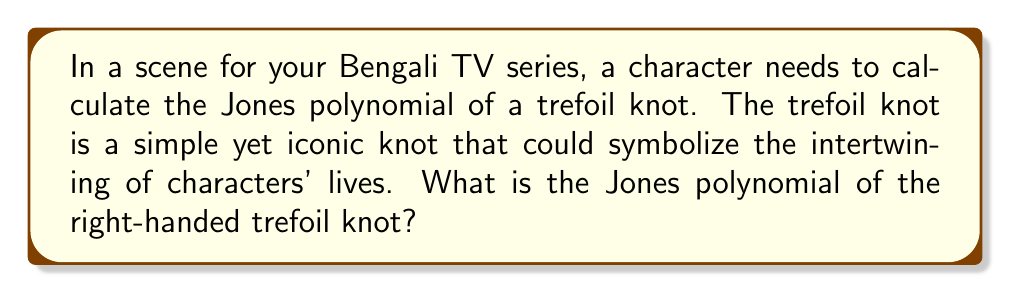Can you solve this math problem? To compute the Jones polynomial of the right-handed trefoil knot, we'll follow these steps:

1. First, we need to orient the trefoil knot and create its diagram:

[asy]
import geometry;

path p = (0,0){dir(60)}..{dir(-60)}(1,0){dir(120)}..{dir(0)}(2,0){dir(-120)}..{dir(180)}cycle;
draw(p, arrow=Arrow(TeXHead));
dot((0,0));
dot((1,0));
dot((2,0));
label("1", (0,0), SW);
label("2", (1,0), S);
label("3", (2,0), SE);
[/asy]

2. We'll use the Kauffman bracket polynomial and then convert it to the Jones polynomial.

3. The Kauffman bracket is calculated using the skein relation:
   $$\langle L_+ \rangle = A\langle L_0 \rangle + A^{-1}\langle L_\infty \rangle$$
   where $A$ is a variable, $L_+$ is the original crossing, $L_0$ is the smoothing that follows the orientation, and $L_\infty$ is the other smoothing.

4. Applying this to each crossing of the trefoil:
   $$\langle \text{trefoil} \rangle = A\langle \text{unknot} \rangle + A^{-1}\langle \text{Hopf link} \rangle$$
   $$= A(-A^2 - A^{-2}) + A^{-1}(-A^3)$$
   $$= -A^3 - A^{-1} - A^{-4}$$

5. The Kauffman bracket of the unknot is $(-A^2 - A^{-2})$, and for the Hopf link, it's $(-A^3)$.

6. To convert the Kauffman bracket to the Jones polynomial, we use:
   $$V_L(t) = (-A^3)^{-w(L)} \langle L \rangle |_{A = t^{-1/4}}$$
   where $w(L)$ is the writhe of the knot (sum of crossing signs).

7. For the right-handed trefoil, $w(L) = 3$.

8. Substituting:
   $$V_L(t) = (-A^3)^{-3} (-A^3 - A^{-1} - A^{-4}) |_{A = t^{-1/4}}$$
   $$= (-A^{-9}) (-A^3 - A^{-1} - A^{-4}) |_{A = t^{-1/4}}$$
   $$= (A^{-6} + A^{-10} + A^{-13}) |_{A = t^{-1/4}}$$
   $$= t + t^3 - t^4$$
Answer: $t + t^3 - t^4$ 